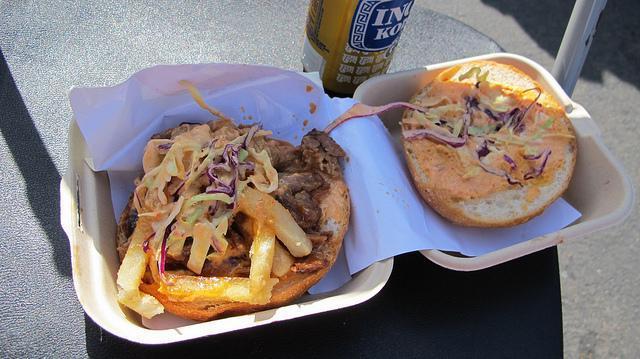How many bowls are there?
Give a very brief answer. 2. 